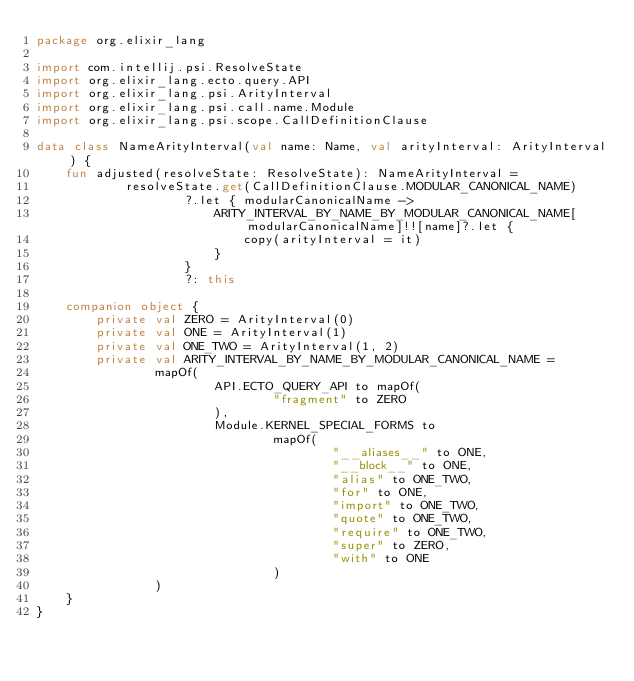<code> <loc_0><loc_0><loc_500><loc_500><_Kotlin_>package org.elixir_lang

import com.intellij.psi.ResolveState
import org.elixir_lang.ecto.query.API
import org.elixir_lang.psi.ArityInterval
import org.elixir_lang.psi.call.name.Module
import org.elixir_lang.psi.scope.CallDefinitionClause

data class NameArityInterval(val name: Name, val arityInterval: ArityInterval) {
    fun adjusted(resolveState: ResolveState): NameArityInterval =
            resolveState.get(CallDefinitionClause.MODULAR_CANONICAL_NAME)
                    ?.let { modularCanonicalName ->
                        ARITY_INTERVAL_BY_NAME_BY_MODULAR_CANONICAL_NAME[modularCanonicalName]!![name]?.let {
                            copy(arityInterval = it)
                        }
                    }
                    ?: this

    companion object {
        private val ZERO = ArityInterval(0)
        private val ONE = ArityInterval(1)
        private val ONE_TWO = ArityInterval(1, 2)
        private val ARITY_INTERVAL_BY_NAME_BY_MODULAR_CANONICAL_NAME =
                mapOf(
                        API.ECTO_QUERY_API to mapOf(
                                "fragment" to ZERO
                        ),
                        Module.KERNEL_SPECIAL_FORMS to
                                mapOf(
                                        "__aliases__" to ONE,
                                        "__block__" to ONE,
                                        "alias" to ONE_TWO,
                                        "for" to ONE,
                                        "import" to ONE_TWO,
                                        "quote" to ONE_TWO,
                                        "require" to ONE_TWO,
                                        "super" to ZERO,
                                        "with" to ONE
                                )
                )
    }
}
</code> 